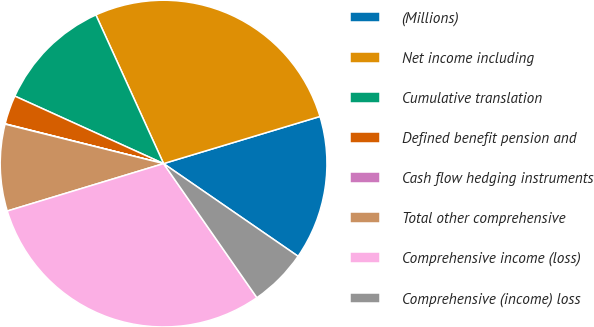Convert chart. <chart><loc_0><loc_0><loc_500><loc_500><pie_chart><fcel>(Millions)<fcel>Net income including<fcel>Cumulative translation<fcel>Defined benefit pension and<fcel>Cash flow hedging instruments<fcel>Total other comprehensive<fcel>Comprehensive income (loss)<fcel>Comprehensive (income) loss<nl><fcel>14.26%<fcel>27.14%<fcel>11.42%<fcel>2.87%<fcel>0.03%<fcel>8.57%<fcel>29.99%<fcel>5.72%<nl></chart> 